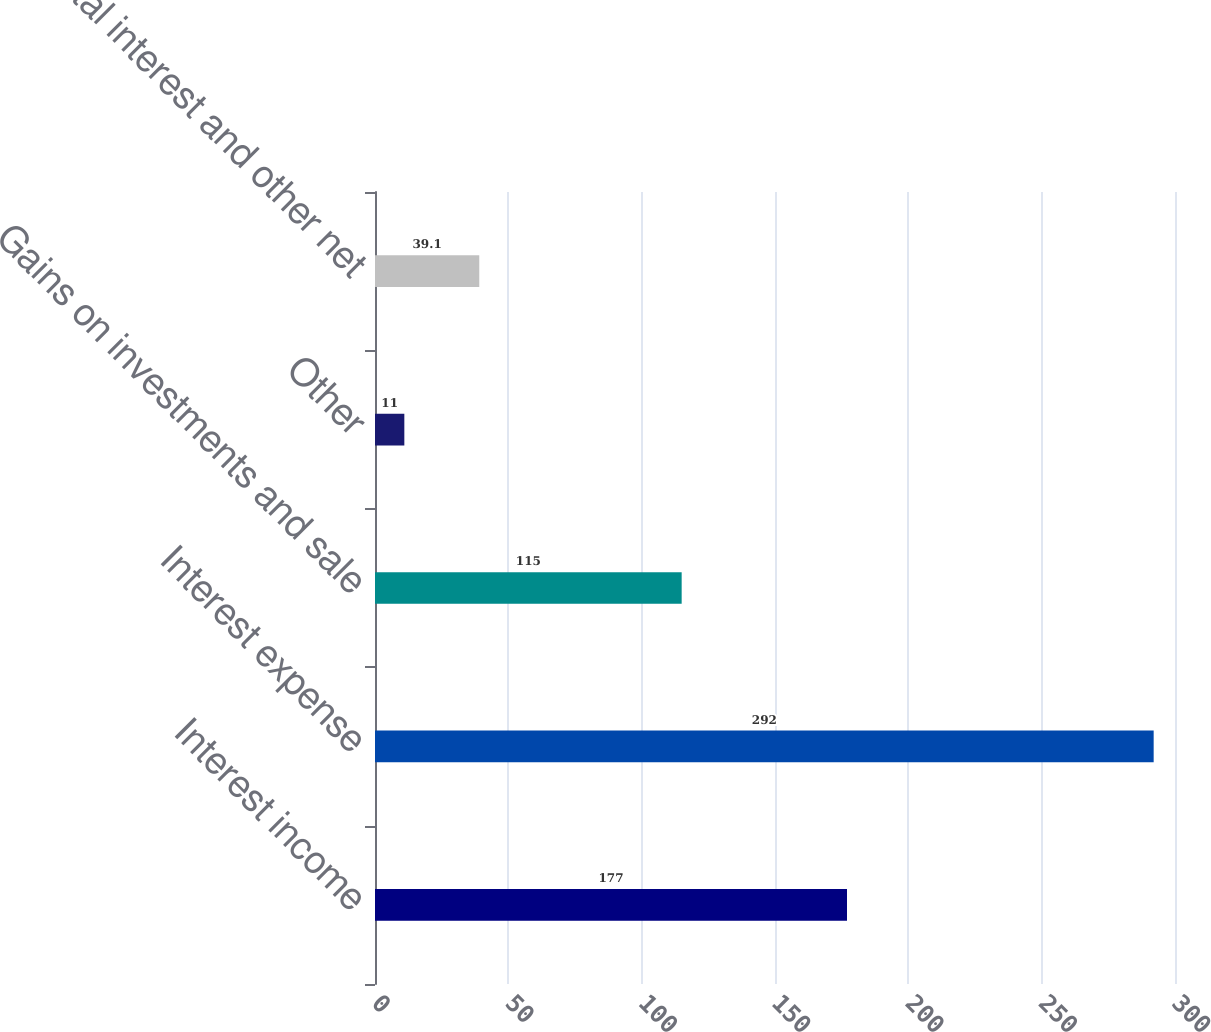Convert chart to OTSL. <chart><loc_0><loc_0><loc_500><loc_500><bar_chart><fcel>Interest income<fcel>Interest expense<fcel>Gains on investments and sale<fcel>Other<fcel>Total interest and other net<nl><fcel>177<fcel>292<fcel>115<fcel>11<fcel>39.1<nl></chart> 